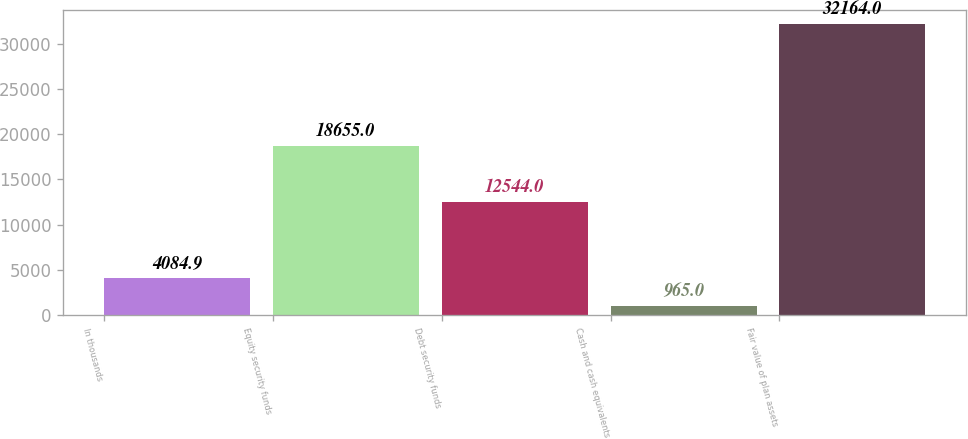<chart> <loc_0><loc_0><loc_500><loc_500><bar_chart><fcel>In thousands<fcel>Equity security funds<fcel>Debt security funds<fcel>Cash and cash equivalents<fcel>Fair value of plan assets<nl><fcel>4084.9<fcel>18655<fcel>12544<fcel>965<fcel>32164<nl></chart> 